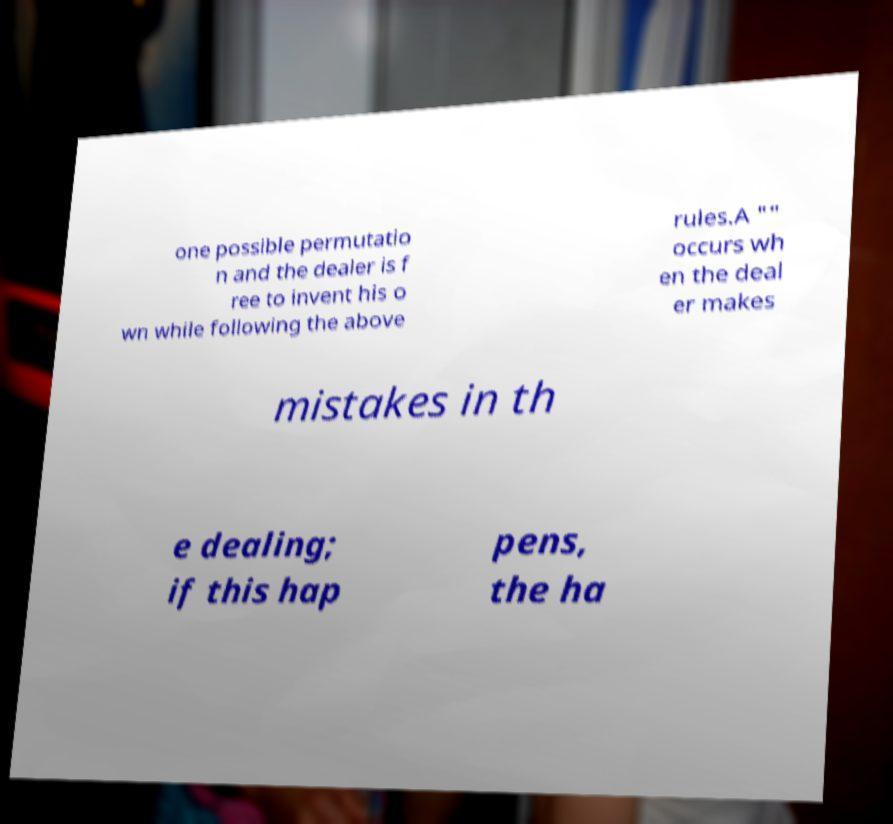Could you extract and type out the text from this image? one possible permutatio n and the dealer is f ree to invent his o wn while following the above rules.A "" occurs wh en the deal er makes mistakes in th e dealing; if this hap pens, the ha 